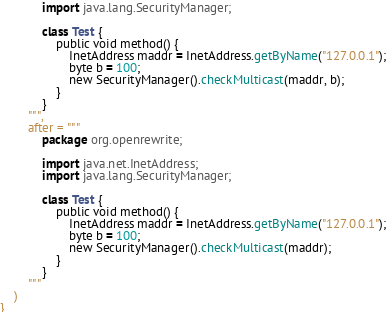<code> <loc_0><loc_0><loc_500><loc_500><_Kotlin_>            import java.lang.SecurityManager;

            class Test {
                public void method() {
                    InetAddress maddr = InetAddress.getByName("127.0.0.1");
                    byte b = 100;
                    new SecurityManager().checkMulticast(maddr, b);
                }
            }
        """,
        after = """
            package org.openrewrite;

            import java.net.InetAddress;
            import java.lang.SecurityManager;

            class Test {
                public void method() {
                    InetAddress maddr = InetAddress.getByName("127.0.0.1");
                    byte b = 100;
                    new SecurityManager().checkMulticast(maddr);
                }
            }
        """
    )
}
</code> 